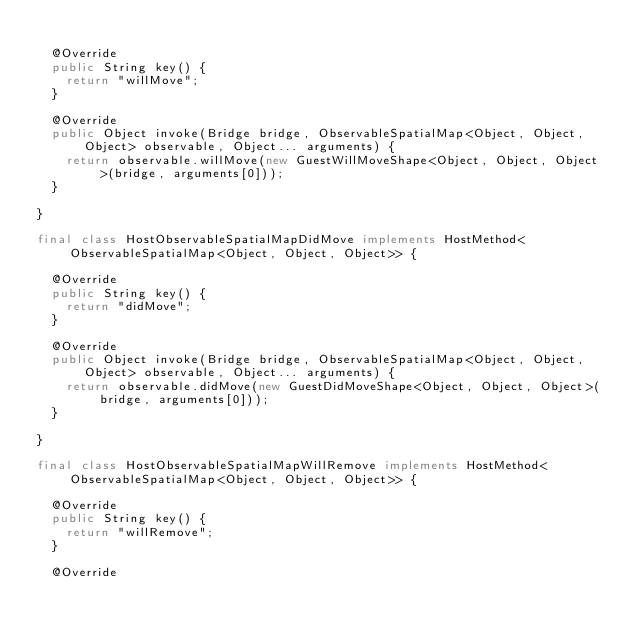Convert code to text. <code><loc_0><loc_0><loc_500><loc_500><_Java_>
  @Override
  public String key() {
    return "willMove";
  }

  @Override
  public Object invoke(Bridge bridge, ObservableSpatialMap<Object, Object, Object> observable, Object... arguments) {
    return observable.willMove(new GuestWillMoveShape<Object, Object, Object>(bridge, arguments[0]));
  }

}

final class HostObservableSpatialMapDidMove implements HostMethod<ObservableSpatialMap<Object, Object, Object>> {

  @Override
  public String key() {
    return "didMove";
  }

  @Override
  public Object invoke(Bridge bridge, ObservableSpatialMap<Object, Object, Object> observable, Object... arguments) {
    return observable.didMove(new GuestDidMoveShape<Object, Object, Object>(bridge, arguments[0]));
  }

}

final class HostObservableSpatialMapWillRemove implements HostMethod<ObservableSpatialMap<Object, Object, Object>> {

  @Override
  public String key() {
    return "willRemove";
  }

  @Override</code> 